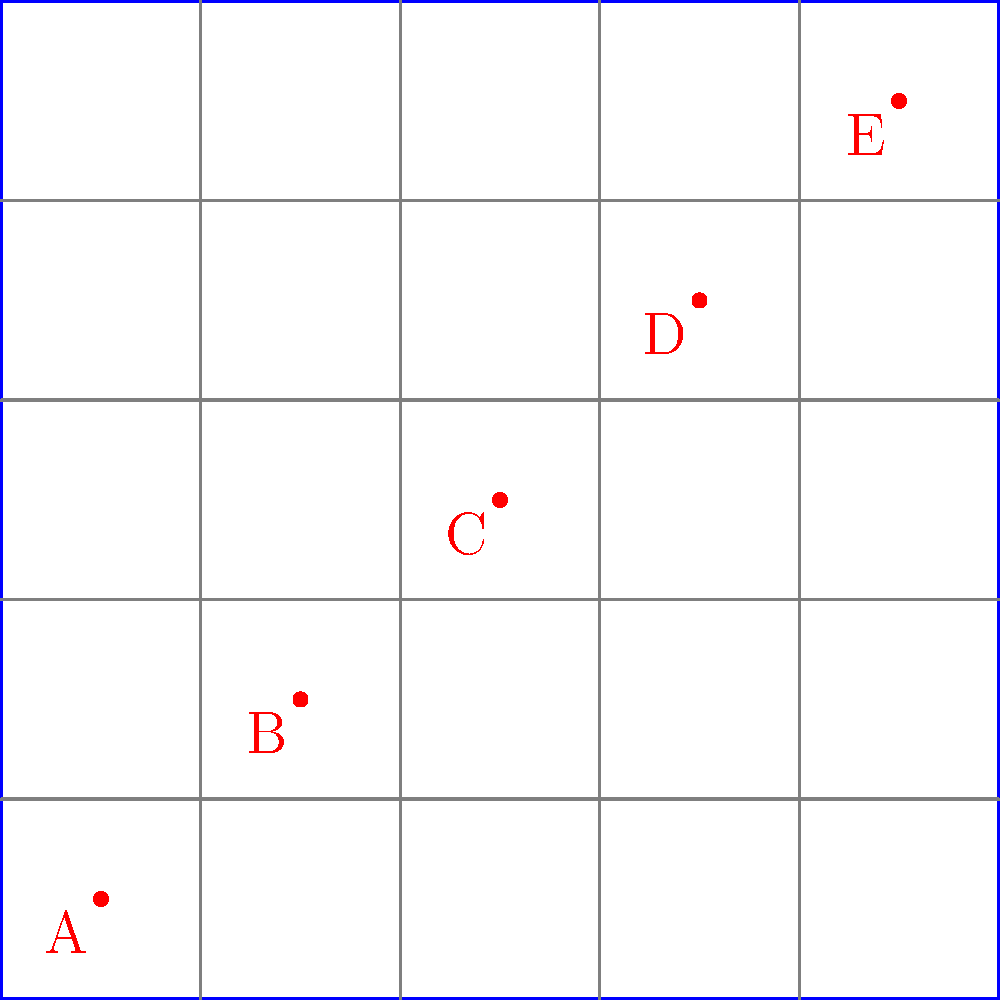You're choreographing a spectacular dance number for your next musical film. Using the grid-based floor plan above, where each cell represents a 5x5 foot area, you've placed 5 dancers (A, B, C, D, and E) along the diagonal. If the dancers need to maintain a minimum distance of 10 feet from each other for a spinning move, what is the maximum number of dancers that can perform this move simultaneously? To solve this problem, we need to follow these steps:

1. Understand the scale: Each cell in the grid represents a 5x5 foot area.

2. Calculate the distance between adjacent dancers:
   - The dancers are placed in a diagonal line, one cell apart.
   - The diagonal of a 5x5 foot square can be calculated using the Pythagorean theorem:
     $$\sqrt{5^2 + 5^2} = \sqrt{50} \approx 7.07$$ feet

3. Compare this distance to the required minimum:
   - The calculated distance (approximately 7.07 feet) is less than the required 10 feet.

4. Determine the required spacing:
   - To maintain a 10-foot distance, dancers need to be at least 2 cells apart diagonally.

5. Count the maximum number of dancers:
   - Starting from one corner, we can select every other dancer.
   - This allows us to choose 3 dancers: A, C, and E.

Therefore, the maximum number of dancers that can perform the spinning move simultaneously while maintaining the required distance is 3.
Answer: 3 dancers 